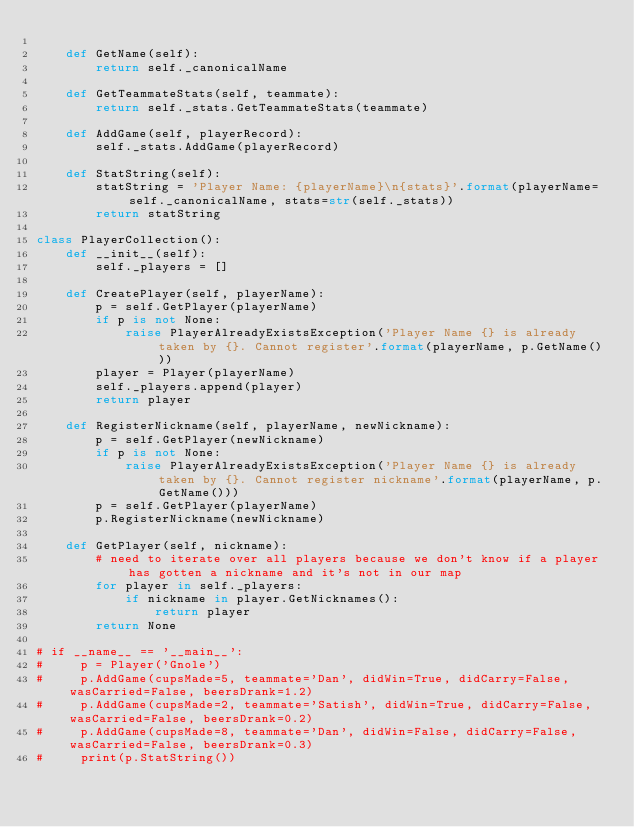Convert code to text. <code><loc_0><loc_0><loc_500><loc_500><_Python_>
    def GetName(self):
        return self._canonicalName

    def GetTeammateStats(self, teammate):
        return self._stats.GetTeammateStats(teammate)

    def AddGame(self, playerRecord):
        self._stats.AddGame(playerRecord)

    def StatString(self):
        statString = 'Player Name: {playerName}\n{stats}'.format(playerName=self._canonicalName, stats=str(self._stats))
        return statString

class PlayerCollection():
    def __init__(self):
        self._players = []

    def CreatePlayer(self, playerName):
        p = self.GetPlayer(playerName)
        if p is not None:
            raise PlayerAlreadyExistsException('Player Name {} is already taken by {}. Cannot register'.format(playerName, p.GetName()))
        player = Player(playerName)
        self._players.append(player)
        return player

    def RegisterNickname(self, playerName, newNickname):
        p = self.GetPlayer(newNickname)
        if p is not None:
            raise PlayerAlreadyExistsException('Player Name {} is already taken by {}. Cannot register nickname'.format(playerName, p.GetName()))
        p = self.GetPlayer(playerName)
        p.RegisterNickname(newNickname)

    def GetPlayer(self, nickname):
        # need to iterate over all players because we don't know if a player has gotten a nickname and it's not in our map
        for player in self._players:
            if nickname in player.GetNicknames():
                return player
        return None

# if __name__ == '__main__':
#     p = Player('Gnole')
#     p.AddGame(cupsMade=5, teammate='Dan', didWin=True, didCarry=False, wasCarried=False, beersDrank=1.2)
#     p.AddGame(cupsMade=2, teammate='Satish', didWin=True, didCarry=False, wasCarried=False, beersDrank=0.2)
#     p.AddGame(cupsMade=8, teammate='Dan', didWin=False, didCarry=False, wasCarried=False, beersDrank=0.3)
#     print(p.StatString())
</code> 